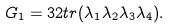<formula> <loc_0><loc_0><loc_500><loc_500>G _ { 1 } = 3 2 t r ( \lambda _ { 1 } \lambda _ { 2 } \lambda _ { 3 } \lambda _ { 4 } ) .</formula> 